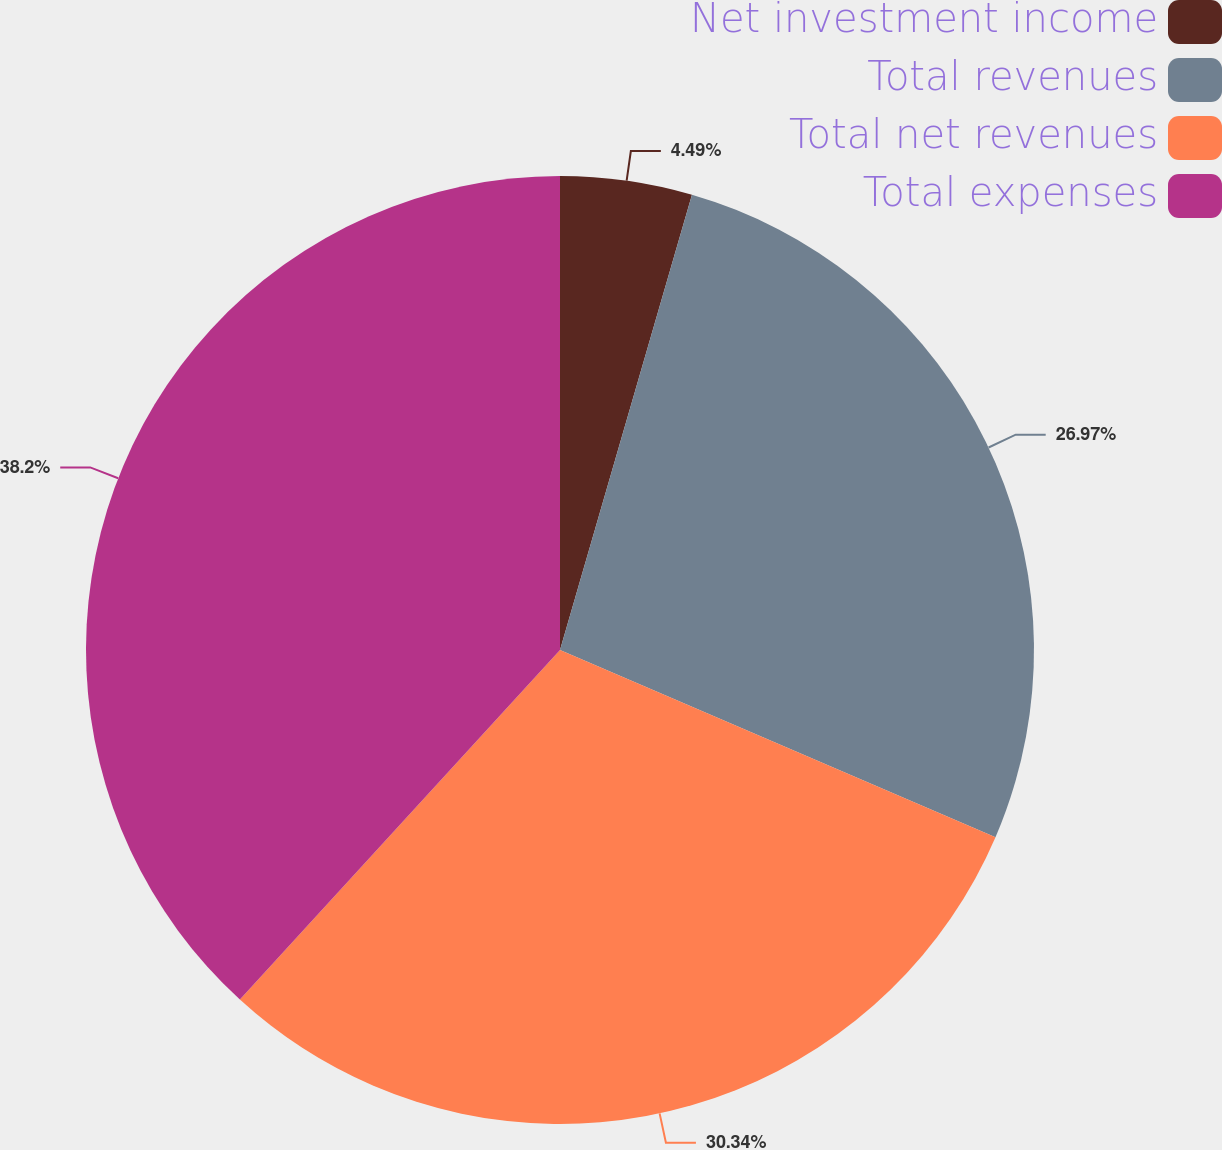<chart> <loc_0><loc_0><loc_500><loc_500><pie_chart><fcel>Net investment income<fcel>Total revenues<fcel>Total net revenues<fcel>Total expenses<nl><fcel>4.49%<fcel>26.97%<fcel>30.34%<fcel>38.2%<nl></chart> 